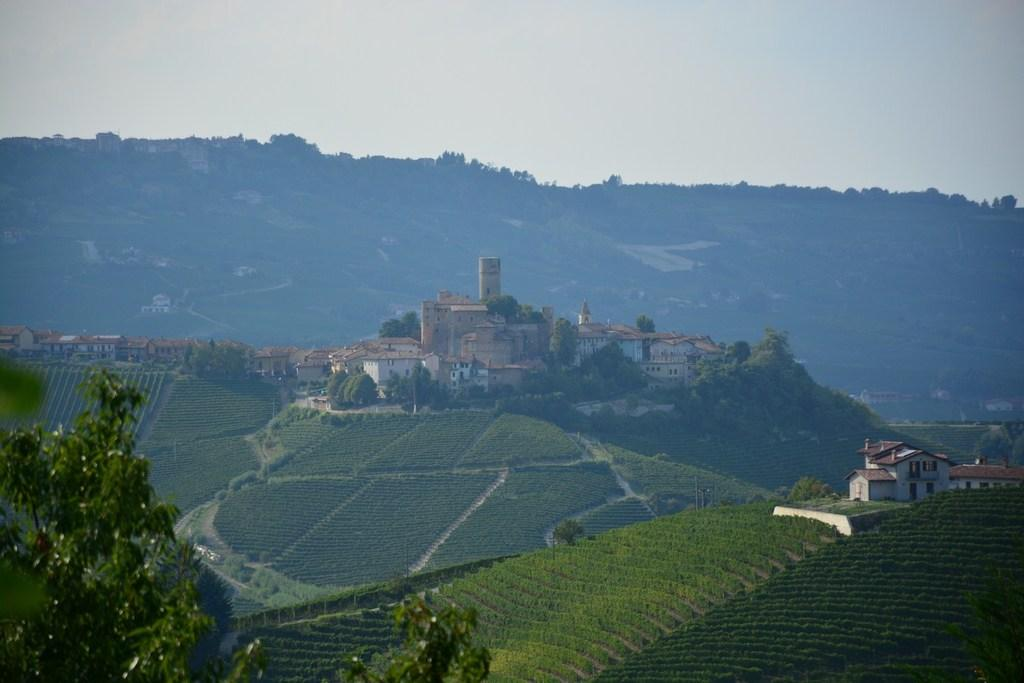What type of living organisms can be seen in the image? Plants and trees are visible in the image. What type of structures can be seen in the image? There are houses in the image. What is visible in the background of the image? The sky is visible in the background of the image. What type of tooth is visible in the image? There is no tooth present in the image. Can you describe the design of the snake in the image? There is no snake present in the image. 